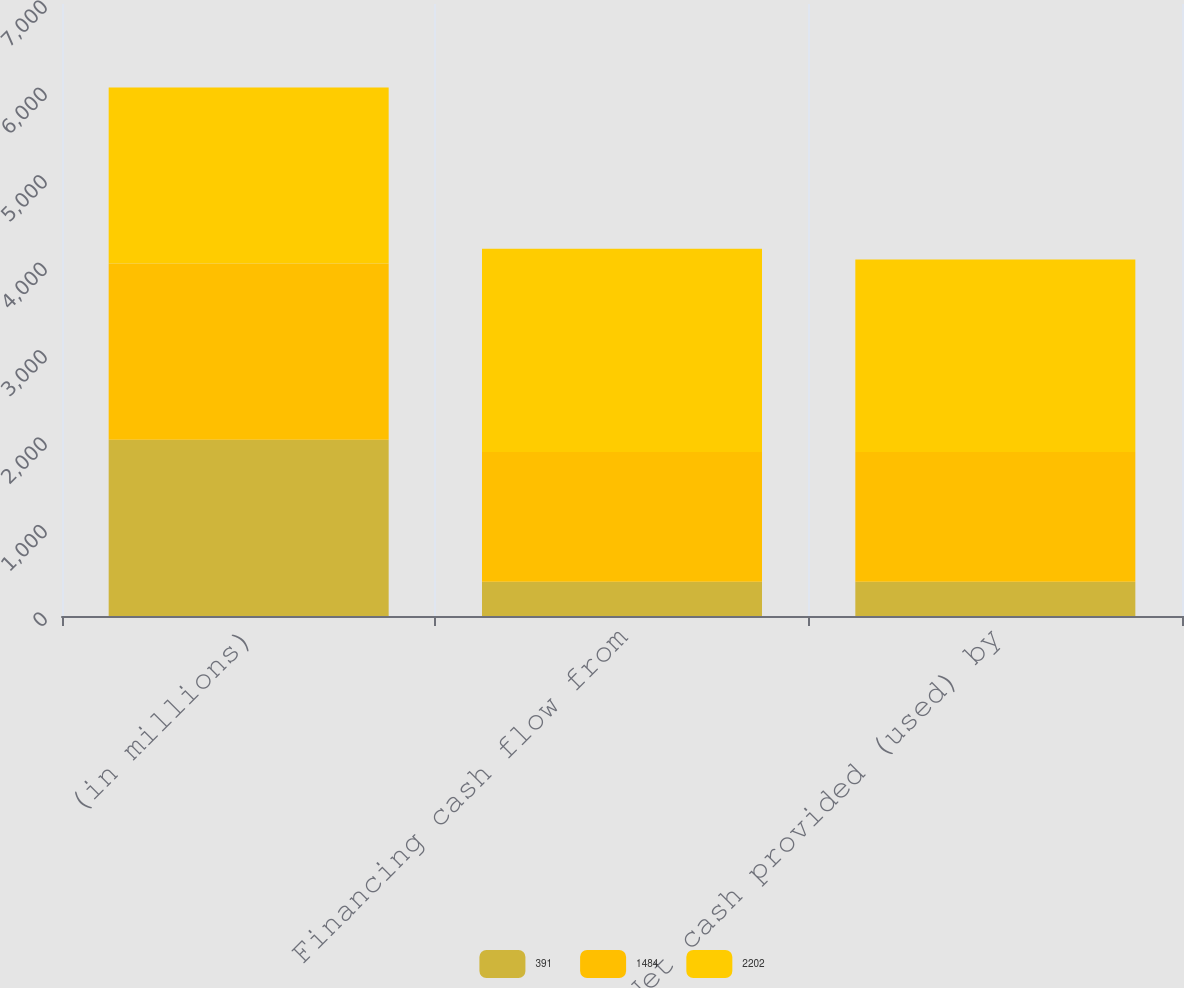Convert chart. <chart><loc_0><loc_0><loc_500><loc_500><stacked_bar_chart><ecel><fcel>(in millions)<fcel>Financing cash flow from<fcel>Net cash provided (used) by<nl><fcel>391<fcel>2016<fcel>391<fcel>391<nl><fcel>1484<fcel>2015<fcel>1484<fcel>1484<nl><fcel>2202<fcel>2014<fcel>2326<fcel>2202<nl></chart> 